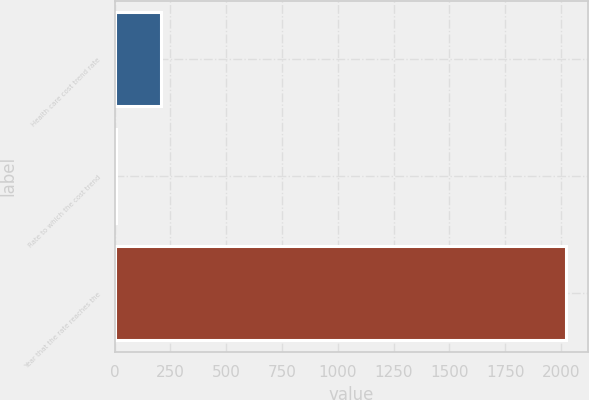<chart> <loc_0><loc_0><loc_500><loc_500><bar_chart><fcel>Health care cost trend rate<fcel>Rate to which the cost trend<fcel>Year that the rate reaches the<nl><fcel>206.5<fcel>5<fcel>2020<nl></chart> 